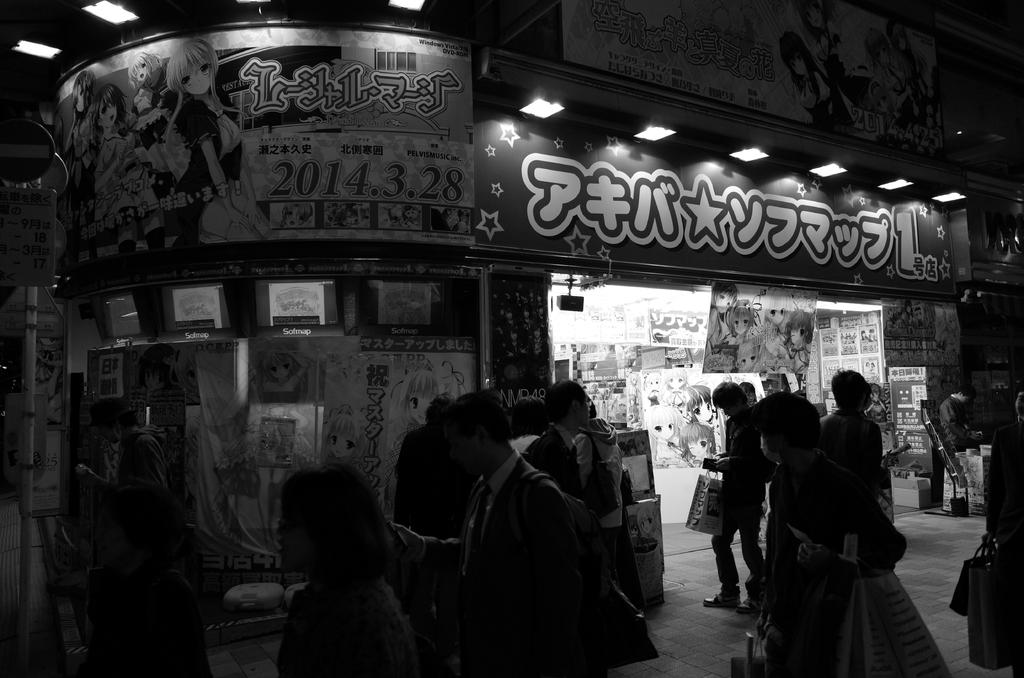What type of establishment is shown in the image? There is a store in the image. What can be seen on the walls of the store? There are posters pasted on the walls in the image. What is located at the top of the image? There are lights at the top of the image. Are there any people present in the image? Yes, there are people in the image. What is on the left side of the image? There is a sign board on the left side of the image. What is the condition of the alley behind the store in the image? There is no alley visible in the image; it only shows the store, lights, posters, and people. 